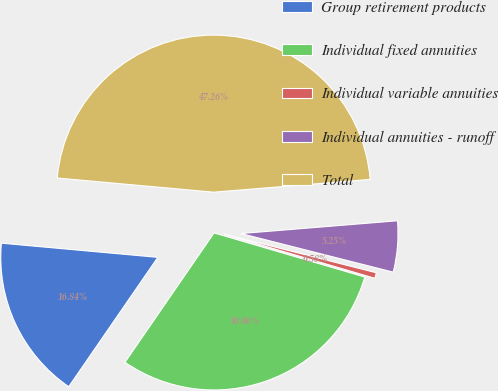Convert chart to OTSL. <chart><loc_0><loc_0><loc_500><loc_500><pie_chart><fcel>Group retirement products<fcel>Individual fixed annuities<fcel>Individual variable annuities<fcel>Individual annuities - runoff<fcel>Total<nl><fcel>16.84%<fcel>30.06%<fcel>0.58%<fcel>5.25%<fcel>47.26%<nl></chart> 